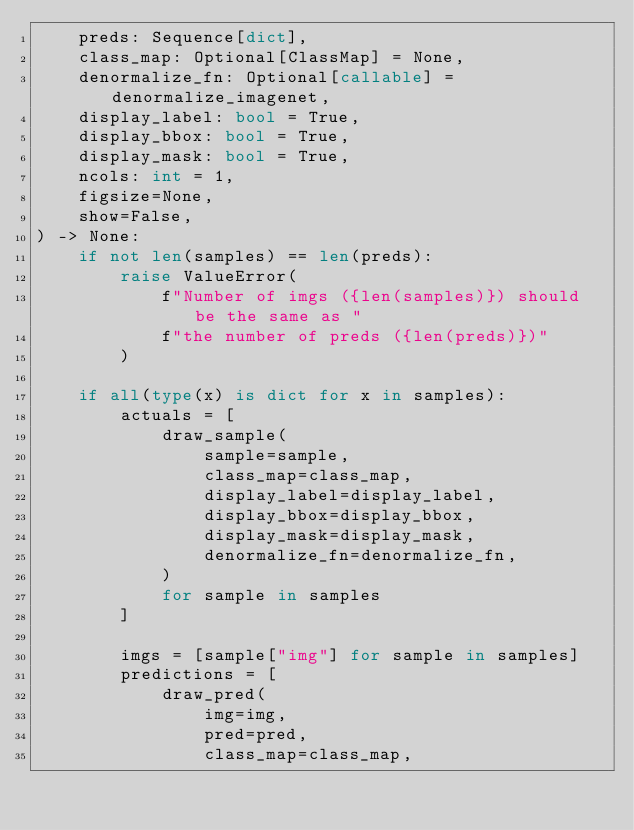Convert code to text. <code><loc_0><loc_0><loc_500><loc_500><_Python_>    preds: Sequence[dict],
    class_map: Optional[ClassMap] = None,
    denormalize_fn: Optional[callable] = denormalize_imagenet,
    display_label: bool = True,
    display_bbox: bool = True,
    display_mask: bool = True,
    ncols: int = 1,
    figsize=None,
    show=False,
) -> None:
    if not len(samples) == len(preds):
        raise ValueError(
            f"Number of imgs ({len(samples)}) should be the same as "
            f"the number of preds ({len(preds)})"
        )

    if all(type(x) is dict for x in samples):
        actuals = [
            draw_sample(
                sample=sample,
                class_map=class_map,
                display_label=display_label,
                display_bbox=display_bbox,
                display_mask=display_mask,
                denormalize_fn=denormalize_fn,
            )
            for sample in samples
        ]

        imgs = [sample["img"] for sample in samples]
        predictions = [
            draw_pred(
                img=img,
                pred=pred,
                class_map=class_map,</code> 